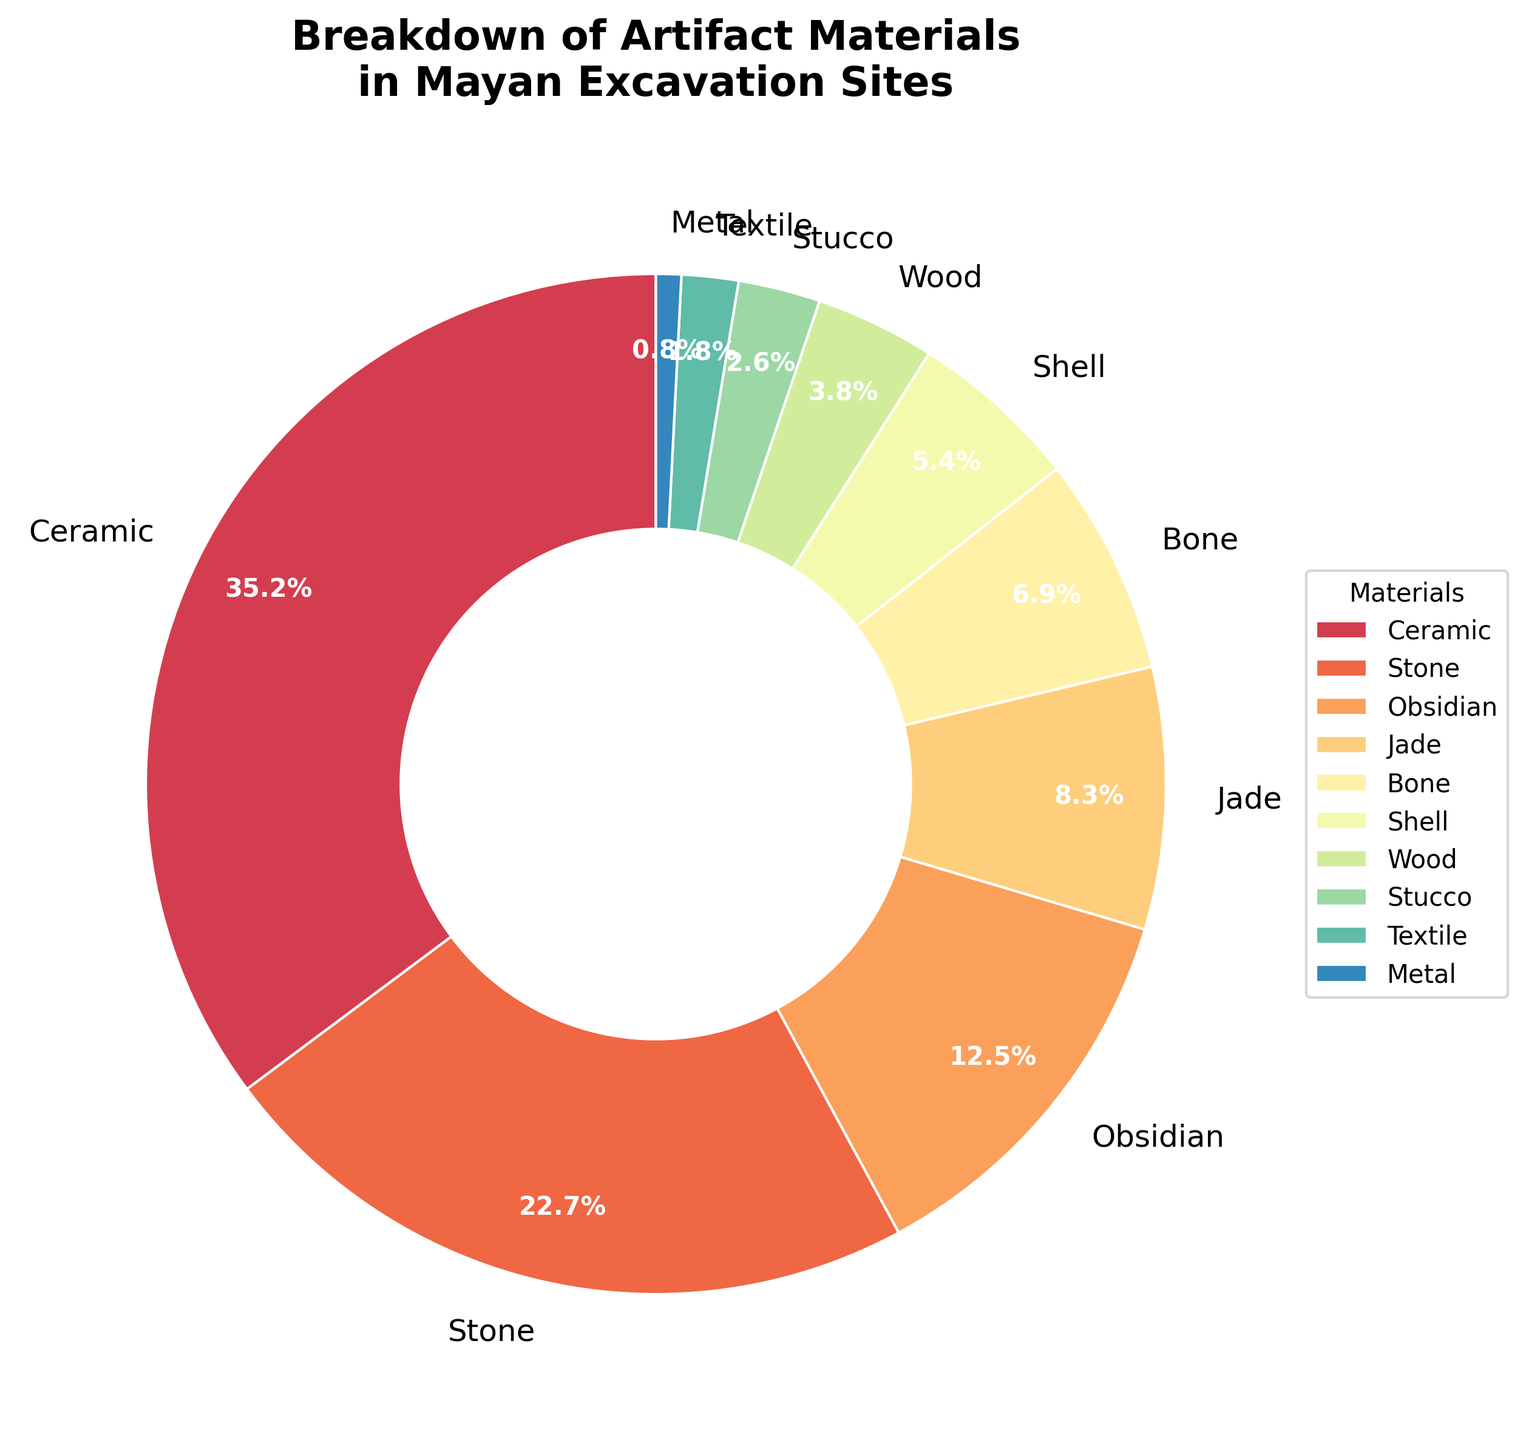What's the most common material found in Mayan excavation sites? The figure shows that Ceramic occupies the largest portion of the pie chart with a percentage of 35.2%.
Answer: Ceramic Which material is found in greater quantities: Jade or Bone? According to the chart, Jade has a percentage of 8.3%, while Bone has 6.9%. Thus, Jade is found in greater quantities.
Answer: Jade What is the total percentage of Stone and Obsidian artifacts combined? Stone constitutes 22.7% and Obsidian constitutes 12.5%. Summing these gives us 22.7 + 12.5 = 35.2%.
Answer: 35.2% Which has a larger percentage, Wood or Shell? From the chart, Shell has a percentage of 5.4%, whereas Wood has 3.8%. Thus, Shell has a larger percentage.
Answer: Shell What percentage of artifacts are made of materials other than Ceramic, Stone, and Obsidian? Ceramic, Stone, and Obsidian sum up to 35.2 + 22.7 + 12.5 = 70.4%. Subtracting this from 100% gives 100 - 70.4 = 29.6%.
Answer: 29.6% Is the percentage of Bone artifacts greater than or less than half the percentage of Ceramic artifacts? The percentage of Bone artifacts is 6.9%. Half the percentage of Ceramic artifacts is 35.2/2 = 17.6%. Therefore, 6.9% is less than 17.6%.
Answer: Less than How many times greater is the percentage of Ceramic artifacts compared to Textile artifacts? Ceramic artifacts are 35.2% while Textile is 1.8%. The ratio is 35.2 / 1.8 ≈ 19.56 times.
Answer: Approximately 19.56 times Which material has the lowest percentage and what is that percentage? From the pie chart, Metal has the lowest percentage at 0.8%.
Answer: Metal, 0.8% If you combine the percentages for Stucco, Textile, and Metal, does it exceed the percentage of Obsidian artifacts? Stucco (2.6%) + Textile (1.8%) + Metal (0.8%) = 2.6 + 1.8 + 0.8 = 5.2%. Obsidian is 12.5%, hence 5.2% does not exceed 12.5%.
Answer: No Compare the visual attributes of the segments representing Ceramic and Stone. Which one appears larger and by what color are they represented? The segment for Ceramic is larger than that for Stone. Ceramic is represented by a mostly warm color scheme (closer to orange) and Stone by a cooler color (closer to green).
Answer: Ceramic, orange and green 